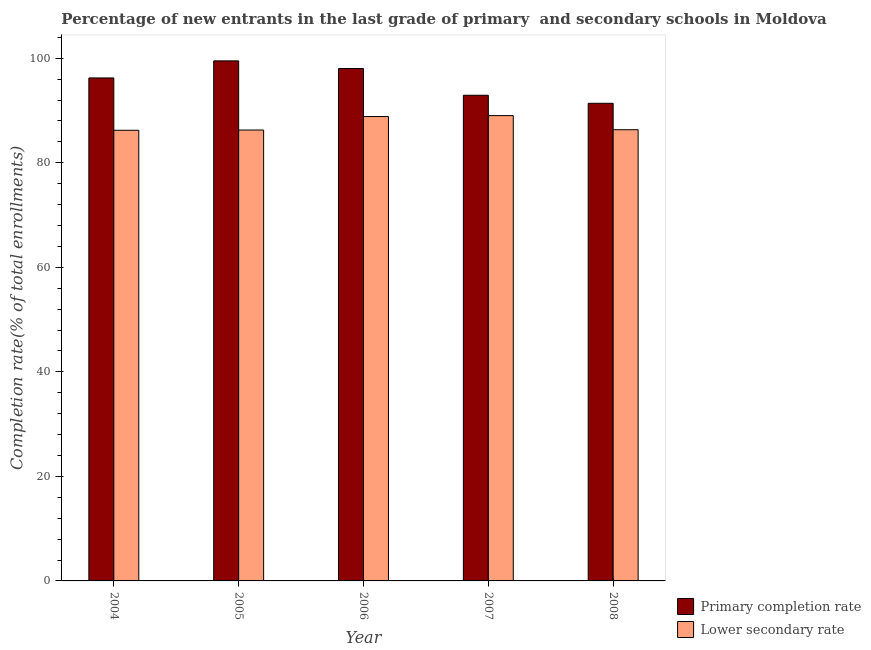How many groups of bars are there?
Make the answer very short. 5. Are the number of bars per tick equal to the number of legend labels?
Offer a terse response. Yes. Are the number of bars on each tick of the X-axis equal?
Give a very brief answer. Yes. How many bars are there on the 2nd tick from the right?
Make the answer very short. 2. What is the label of the 5th group of bars from the left?
Provide a succinct answer. 2008. In how many cases, is the number of bars for a given year not equal to the number of legend labels?
Offer a terse response. 0. What is the completion rate in primary schools in 2005?
Offer a very short reply. 99.49. Across all years, what is the maximum completion rate in secondary schools?
Offer a terse response. 89.02. Across all years, what is the minimum completion rate in primary schools?
Your answer should be compact. 91.38. What is the total completion rate in primary schools in the graph?
Provide a succinct answer. 478.03. What is the difference between the completion rate in secondary schools in 2006 and that in 2007?
Make the answer very short. -0.18. What is the difference between the completion rate in primary schools in 2008 and the completion rate in secondary schools in 2007?
Make the answer very short. -1.54. What is the average completion rate in primary schools per year?
Provide a succinct answer. 95.61. In the year 2004, what is the difference between the completion rate in primary schools and completion rate in secondary schools?
Make the answer very short. 0. What is the ratio of the completion rate in secondary schools in 2005 to that in 2007?
Provide a short and direct response. 0.97. Is the difference between the completion rate in secondary schools in 2005 and 2006 greater than the difference between the completion rate in primary schools in 2005 and 2006?
Your response must be concise. No. What is the difference between the highest and the second highest completion rate in primary schools?
Offer a terse response. 1.46. What is the difference between the highest and the lowest completion rate in primary schools?
Offer a terse response. 8.11. In how many years, is the completion rate in primary schools greater than the average completion rate in primary schools taken over all years?
Offer a very short reply. 3. Is the sum of the completion rate in primary schools in 2007 and 2008 greater than the maximum completion rate in secondary schools across all years?
Your answer should be compact. Yes. What does the 1st bar from the left in 2008 represents?
Provide a short and direct response. Primary completion rate. What does the 1st bar from the right in 2006 represents?
Your answer should be very brief. Lower secondary rate. What is the difference between two consecutive major ticks on the Y-axis?
Offer a very short reply. 20. Are the values on the major ticks of Y-axis written in scientific E-notation?
Give a very brief answer. No. Does the graph contain any zero values?
Offer a terse response. No. Does the graph contain grids?
Your answer should be compact. No. How many legend labels are there?
Ensure brevity in your answer.  2. How are the legend labels stacked?
Provide a succinct answer. Vertical. What is the title of the graph?
Provide a succinct answer. Percentage of new entrants in the last grade of primary  and secondary schools in Moldova. Does "Domestic Liabilities" appear as one of the legend labels in the graph?
Offer a terse response. No. What is the label or title of the Y-axis?
Give a very brief answer. Completion rate(% of total enrollments). What is the Completion rate(% of total enrollments) of Primary completion rate in 2004?
Make the answer very short. 96.22. What is the Completion rate(% of total enrollments) in Lower secondary rate in 2004?
Make the answer very short. 86.21. What is the Completion rate(% of total enrollments) of Primary completion rate in 2005?
Your answer should be very brief. 99.49. What is the Completion rate(% of total enrollments) of Lower secondary rate in 2005?
Offer a terse response. 86.26. What is the Completion rate(% of total enrollments) in Primary completion rate in 2006?
Offer a very short reply. 98.03. What is the Completion rate(% of total enrollments) of Lower secondary rate in 2006?
Your answer should be compact. 88.84. What is the Completion rate(% of total enrollments) of Primary completion rate in 2007?
Offer a terse response. 92.91. What is the Completion rate(% of total enrollments) in Lower secondary rate in 2007?
Ensure brevity in your answer.  89.02. What is the Completion rate(% of total enrollments) of Primary completion rate in 2008?
Offer a very short reply. 91.38. What is the Completion rate(% of total enrollments) in Lower secondary rate in 2008?
Ensure brevity in your answer.  86.32. Across all years, what is the maximum Completion rate(% of total enrollments) of Primary completion rate?
Give a very brief answer. 99.49. Across all years, what is the maximum Completion rate(% of total enrollments) of Lower secondary rate?
Offer a terse response. 89.02. Across all years, what is the minimum Completion rate(% of total enrollments) in Primary completion rate?
Offer a terse response. 91.38. Across all years, what is the minimum Completion rate(% of total enrollments) in Lower secondary rate?
Give a very brief answer. 86.21. What is the total Completion rate(% of total enrollments) of Primary completion rate in the graph?
Give a very brief answer. 478.03. What is the total Completion rate(% of total enrollments) of Lower secondary rate in the graph?
Offer a very short reply. 436.65. What is the difference between the Completion rate(% of total enrollments) of Primary completion rate in 2004 and that in 2005?
Offer a terse response. -3.27. What is the difference between the Completion rate(% of total enrollments) in Lower secondary rate in 2004 and that in 2005?
Ensure brevity in your answer.  -0.05. What is the difference between the Completion rate(% of total enrollments) of Primary completion rate in 2004 and that in 2006?
Make the answer very short. -1.81. What is the difference between the Completion rate(% of total enrollments) in Lower secondary rate in 2004 and that in 2006?
Provide a succinct answer. -2.63. What is the difference between the Completion rate(% of total enrollments) of Primary completion rate in 2004 and that in 2007?
Provide a short and direct response. 3.31. What is the difference between the Completion rate(% of total enrollments) in Lower secondary rate in 2004 and that in 2007?
Give a very brief answer. -2.81. What is the difference between the Completion rate(% of total enrollments) of Primary completion rate in 2004 and that in 2008?
Offer a very short reply. 4.85. What is the difference between the Completion rate(% of total enrollments) in Lower secondary rate in 2004 and that in 2008?
Keep it short and to the point. -0.1. What is the difference between the Completion rate(% of total enrollments) of Primary completion rate in 2005 and that in 2006?
Ensure brevity in your answer.  1.46. What is the difference between the Completion rate(% of total enrollments) in Lower secondary rate in 2005 and that in 2006?
Your response must be concise. -2.58. What is the difference between the Completion rate(% of total enrollments) in Primary completion rate in 2005 and that in 2007?
Offer a terse response. 6.58. What is the difference between the Completion rate(% of total enrollments) in Lower secondary rate in 2005 and that in 2007?
Ensure brevity in your answer.  -2.76. What is the difference between the Completion rate(% of total enrollments) in Primary completion rate in 2005 and that in 2008?
Make the answer very short. 8.11. What is the difference between the Completion rate(% of total enrollments) in Lower secondary rate in 2005 and that in 2008?
Offer a terse response. -0.06. What is the difference between the Completion rate(% of total enrollments) in Primary completion rate in 2006 and that in 2007?
Offer a terse response. 5.12. What is the difference between the Completion rate(% of total enrollments) of Lower secondary rate in 2006 and that in 2007?
Keep it short and to the point. -0.18. What is the difference between the Completion rate(% of total enrollments) in Primary completion rate in 2006 and that in 2008?
Your response must be concise. 6.65. What is the difference between the Completion rate(% of total enrollments) of Lower secondary rate in 2006 and that in 2008?
Provide a succinct answer. 2.52. What is the difference between the Completion rate(% of total enrollments) of Primary completion rate in 2007 and that in 2008?
Ensure brevity in your answer.  1.54. What is the difference between the Completion rate(% of total enrollments) in Lower secondary rate in 2007 and that in 2008?
Your answer should be very brief. 2.7. What is the difference between the Completion rate(% of total enrollments) in Primary completion rate in 2004 and the Completion rate(% of total enrollments) in Lower secondary rate in 2005?
Ensure brevity in your answer.  9.96. What is the difference between the Completion rate(% of total enrollments) in Primary completion rate in 2004 and the Completion rate(% of total enrollments) in Lower secondary rate in 2006?
Ensure brevity in your answer.  7.38. What is the difference between the Completion rate(% of total enrollments) of Primary completion rate in 2004 and the Completion rate(% of total enrollments) of Lower secondary rate in 2007?
Provide a short and direct response. 7.2. What is the difference between the Completion rate(% of total enrollments) in Primary completion rate in 2004 and the Completion rate(% of total enrollments) in Lower secondary rate in 2008?
Make the answer very short. 9.91. What is the difference between the Completion rate(% of total enrollments) of Primary completion rate in 2005 and the Completion rate(% of total enrollments) of Lower secondary rate in 2006?
Keep it short and to the point. 10.65. What is the difference between the Completion rate(% of total enrollments) of Primary completion rate in 2005 and the Completion rate(% of total enrollments) of Lower secondary rate in 2007?
Ensure brevity in your answer.  10.47. What is the difference between the Completion rate(% of total enrollments) of Primary completion rate in 2005 and the Completion rate(% of total enrollments) of Lower secondary rate in 2008?
Provide a short and direct response. 13.17. What is the difference between the Completion rate(% of total enrollments) in Primary completion rate in 2006 and the Completion rate(% of total enrollments) in Lower secondary rate in 2007?
Provide a succinct answer. 9.01. What is the difference between the Completion rate(% of total enrollments) in Primary completion rate in 2006 and the Completion rate(% of total enrollments) in Lower secondary rate in 2008?
Your response must be concise. 11.71. What is the difference between the Completion rate(% of total enrollments) of Primary completion rate in 2007 and the Completion rate(% of total enrollments) of Lower secondary rate in 2008?
Your response must be concise. 6.6. What is the average Completion rate(% of total enrollments) in Primary completion rate per year?
Make the answer very short. 95.61. What is the average Completion rate(% of total enrollments) in Lower secondary rate per year?
Your answer should be compact. 87.33. In the year 2004, what is the difference between the Completion rate(% of total enrollments) of Primary completion rate and Completion rate(% of total enrollments) of Lower secondary rate?
Provide a short and direct response. 10.01. In the year 2005, what is the difference between the Completion rate(% of total enrollments) in Primary completion rate and Completion rate(% of total enrollments) in Lower secondary rate?
Your answer should be compact. 13.23. In the year 2006, what is the difference between the Completion rate(% of total enrollments) in Primary completion rate and Completion rate(% of total enrollments) in Lower secondary rate?
Give a very brief answer. 9.19. In the year 2007, what is the difference between the Completion rate(% of total enrollments) in Primary completion rate and Completion rate(% of total enrollments) in Lower secondary rate?
Offer a terse response. 3.89. In the year 2008, what is the difference between the Completion rate(% of total enrollments) of Primary completion rate and Completion rate(% of total enrollments) of Lower secondary rate?
Ensure brevity in your answer.  5.06. What is the ratio of the Completion rate(% of total enrollments) in Primary completion rate in 2004 to that in 2005?
Ensure brevity in your answer.  0.97. What is the ratio of the Completion rate(% of total enrollments) in Lower secondary rate in 2004 to that in 2005?
Provide a short and direct response. 1. What is the ratio of the Completion rate(% of total enrollments) in Primary completion rate in 2004 to that in 2006?
Offer a very short reply. 0.98. What is the ratio of the Completion rate(% of total enrollments) in Lower secondary rate in 2004 to that in 2006?
Offer a terse response. 0.97. What is the ratio of the Completion rate(% of total enrollments) of Primary completion rate in 2004 to that in 2007?
Provide a short and direct response. 1.04. What is the ratio of the Completion rate(% of total enrollments) of Lower secondary rate in 2004 to that in 2007?
Offer a terse response. 0.97. What is the ratio of the Completion rate(% of total enrollments) in Primary completion rate in 2004 to that in 2008?
Ensure brevity in your answer.  1.05. What is the ratio of the Completion rate(% of total enrollments) in Primary completion rate in 2005 to that in 2006?
Ensure brevity in your answer.  1.01. What is the ratio of the Completion rate(% of total enrollments) in Lower secondary rate in 2005 to that in 2006?
Keep it short and to the point. 0.97. What is the ratio of the Completion rate(% of total enrollments) in Primary completion rate in 2005 to that in 2007?
Give a very brief answer. 1.07. What is the ratio of the Completion rate(% of total enrollments) of Primary completion rate in 2005 to that in 2008?
Offer a very short reply. 1.09. What is the ratio of the Completion rate(% of total enrollments) in Lower secondary rate in 2005 to that in 2008?
Provide a succinct answer. 1. What is the ratio of the Completion rate(% of total enrollments) in Primary completion rate in 2006 to that in 2007?
Make the answer very short. 1.06. What is the ratio of the Completion rate(% of total enrollments) in Lower secondary rate in 2006 to that in 2007?
Provide a succinct answer. 1. What is the ratio of the Completion rate(% of total enrollments) of Primary completion rate in 2006 to that in 2008?
Give a very brief answer. 1.07. What is the ratio of the Completion rate(% of total enrollments) in Lower secondary rate in 2006 to that in 2008?
Give a very brief answer. 1.03. What is the ratio of the Completion rate(% of total enrollments) in Primary completion rate in 2007 to that in 2008?
Your response must be concise. 1.02. What is the ratio of the Completion rate(% of total enrollments) of Lower secondary rate in 2007 to that in 2008?
Your answer should be compact. 1.03. What is the difference between the highest and the second highest Completion rate(% of total enrollments) in Primary completion rate?
Provide a succinct answer. 1.46. What is the difference between the highest and the second highest Completion rate(% of total enrollments) in Lower secondary rate?
Offer a terse response. 0.18. What is the difference between the highest and the lowest Completion rate(% of total enrollments) of Primary completion rate?
Offer a terse response. 8.11. What is the difference between the highest and the lowest Completion rate(% of total enrollments) of Lower secondary rate?
Provide a short and direct response. 2.81. 